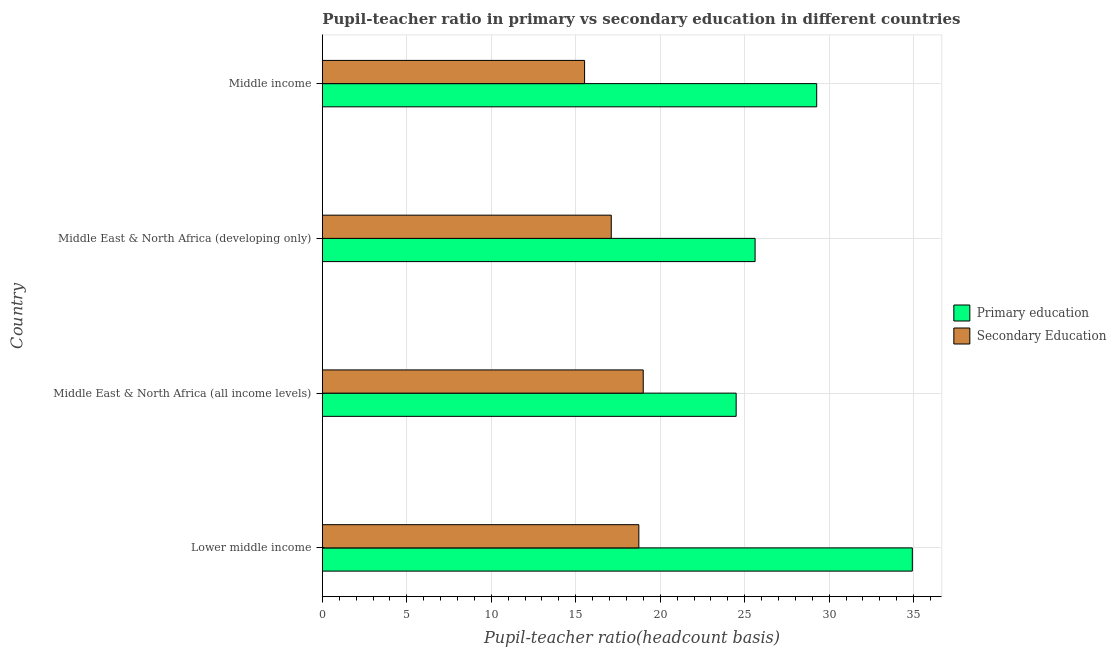How many different coloured bars are there?
Provide a short and direct response. 2. How many groups of bars are there?
Offer a very short reply. 4. Are the number of bars per tick equal to the number of legend labels?
Give a very brief answer. Yes. How many bars are there on the 1st tick from the top?
Your answer should be very brief. 2. How many bars are there on the 2nd tick from the bottom?
Provide a short and direct response. 2. What is the label of the 4th group of bars from the top?
Offer a terse response. Lower middle income. What is the pupil teacher ratio on secondary education in Middle East & North Africa (all income levels)?
Your answer should be compact. 18.99. Across all countries, what is the maximum pupil-teacher ratio in primary education?
Offer a terse response. 34.92. Across all countries, what is the minimum pupil teacher ratio on secondary education?
Ensure brevity in your answer.  15.52. In which country was the pupil-teacher ratio in primary education maximum?
Ensure brevity in your answer.  Lower middle income. In which country was the pupil teacher ratio on secondary education minimum?
Your answer should be compact. Middle income. What is the total pupil teacher ratio on secondary education in the graph?
Your answer should be compact. 70.35. What is the difference between the pupil teacher ratio on secondary education in Lower middle income and that in Middle income?
Ensure brevity in your answer.  3.21. What is the difference between the pupil teacher ratio on secondary education in Middle income and the pupil-teacher ratio in primary education in Middle East & North Africa (developing only)?
Ensure brevity in your answer.  -10.09. What is the average pupil-teacher ratio in primary education per country?
Offer a very short reply. 28.57. What is the difference between the pupil-teacher ratio in primary education and pupil teacher ratio on secondary education in Middle income?
Your response must be concise. 13.74. In how many countries, is the pupil-teacher ratio in primary education greater than 5 ?
Your answer should be compact. 4. What is the ratio of the pupil teacher ratio on secondary education in Lower middle income to that in Middle income?
Your response must be concise. 1.21. Is the pupil teacher ratio on secondary education in Middle East & North Africa (all income levels) less than that in Middle income?
Your response must be concise. No. What is the difference between the highest and the second highest pupil-teacher ratio in primary education?
Your answer should be very brief. 5.66. What is the difference between the highest and the lowest pupil-teacher ratio in primary education?
Ensure brevity in your answer.  10.43. In how many countries, is the pupil-teacher ratio in primary education greater than the average pupil-teacher ratio in primary education taken over all countries?
Offer a very short reply. 2. What does the 2nd bar from the top in Middle income represents?
Ensure brevity in your answer.  Primary education. What does the 1st bar from the bottom in Lower middle income represents?
Provide a short and direct response. Primary education. Are all the bars in the graph horizontal?
Provide a short and direct response. Yes. What is the difference between two consecutive major ticks on the X-axis?
Offer a terse response. 5. Are the values on the major ticks of X-axis written in scientific E-notation?
Make the answer very short. No. Where does the legend appear in the graph?
Give a very brief answer. Center right. How many legend labels are there?
Your answer should be compact. 2. How are the legend labels stacked?
Offer a terse response. Vertical. What is the title of the graph?
Make the answer very short. Pupil-teacher ratio in primary vs secondary education in different countries. What is the label or title of the X-axis?
Make the answer very short. Pupil-teacher ratio(headcount basis). What is the label or title of the Y-axis?
Provide a succinct answer. Country. What is the Pupil-teacher ratio(headcount basis) in Primary education in Lower middle income?
Keep it short and to the point. 34.92. What is the Pupil-teacher ratio(headcount basis) of Secondary Education in Lower middle income?
Offer a terse response. 18.73. What is the Pupil-teacher ratio(headcount basis) in Primary education in Middle East & North Africa (all income levels)?
Your response must be concise. 24.49. What is the Pupil-teacher ratio(headcount basis) of Secondary Education in Middle East & North Africa (all income levels)?
Offer a very short reply. 18.99. What is the Pupil-teacher ratio(headcount basis) of Primary education in Middle East & North Africa (developing only)?
Provide a short and direct response. 25.61. What is the Pupil-teacher ratio(headcount basis) in Secondary Education in Middle East & North Africa (developing only)?
Provide a short and direct response. 17.1. What is the Pupil-teacher ratio(headcount basis) of Primary education in Middle income?
Offer a very short reply. 29.26. What is the Pupil-teacher ratio(headcount basis) in Secondary Education in Middle income?
Your answer should be very brief. 15.52. Across all countries, what is the maximum Pupil-teacher ratio(headcount basis) of Primary education?
Give a very brief answer. 34.92. Across all countries, what is the maximum Pupil-teacher ratio(headcount basis) of Secondary Education?
Offer a terse response. 18.99. Across all countries, what is the minimum Pupil-teacher ratio(headcount basis) of Primary education?
Your answer should be very brief. 24.49. Across all countries, what is the minimum Pupil-teacher ratio(headcount basis) of Secondary Education?
Your response must be concise. 15.52. What is the total Pupil-teacher ratio(headcount basis) of Primary education in the graph?
Offer a very short reply. 114.29. What is the total Pupil-teacher ratio(headcount basis) of Secondary Education in the graph?
Your answer should be very brief. 70.35. What is the difference between the Pupil-teacher ratio(headcount basis) of Primary education in Lower middle income and that in Middle East & North Africa (all income levels)?
Keep it short and to the point. 10.43. What is the difference between the Pupil-teacher ratio(headcount basis) in Secondary Education in Lower middle income and that in Middle East & North Africa (all income levels)?
Provide a succinct answer. -0.26. What is the difference between the Pupil-teacher ratio(headcount basis) in Primary education in Lower middle income and that in Middle East & North Africa (developing only)?
Make the answer very short. 9.31. What is the difference between the Pupil-teacher ratio(headcount basis) in Secondary Education in Lower middle income and that in Middle East & North Africa (developing only)?
Offer a very short reply. 1.63. What is the difference between the Pupil-teacher ratio(headcount basis) in Primary education in Lower middle income and that in Middle income?
Provide a succinct answer. 5.66. What is the difference between the Pupil-teacher ratio(headcount basis) of Secondary Education in Lower middle income and that in Middle income?
Ensure brevity in your answer.  3.21. What is the difference between the Pupil-teacher ratio(headcount basis) in Primary education in Middle East & North Africa (all income levels) and that in Middle East & North Africa (developing only)?
Your answer should be compact. -1.12. What is the difference between the Pupil-teacher ratio(headcount basis) in Secondary Education in Middle East & North Africa (all income levels) and that in Middle East & North Africa (developing only)?
Your response must be concise. 1.89. What is the difference between the Pupil-teacher ratio(headcount basis) of Primary education in Middle East & North Africa (all income levels) and that in Middle income?
Keep it short and to the point. -4.77. What is the difference between the Pupil-teacher ratio(headcount basis) of Secondary Education in Middle East & North Africa (all income levels) and that in Middle income?
Ensure brevity in your answer.  3.47. What is the difference between the Pupil-teacher ratio(headcount basis) of Primary education in Middle East & North Africa (developing only) and that in Middle income?
Keep it short and to the point. -3.65. What is the difference between the Pupil-teacher ratio(headcount basis) in Secondary Education in Middle East & North Africa (developing only) and that in Middle income?
Your response must be concise. 1.58. What is the difference between the Pupil-teacher ratio(headcount basis) of Primary education in Lower middle income and the Pupil-teacher ratio(headcount basis) of Secondary Education in Middle East & North Africa (all income levels)?
Offer a very short reply. 15.93. What is the difference between the Pupil-teacher ratio(headcount basis) in Primary education in Lower middle income and the Pupil-teacher ratio(headcount basis) in Secondary Education in Middle East & North Africa (developing only)?
Provide a succinct answer. 17.82. What is the difference between the Pupil-teacher ratio(headcount basis) in Primary education in Lower middle income and the Pupil-teacher ratio(headcount basis) in Secondary Education in Middle income?
Offer a terse response. 19.4. What is the difference between the Pupil-teacher ratio(headcount basis) of Primary education in Middle East & North Africa (all income levels) and the Pupil-teacher ratio(headcount basis) of Secondary Education in Middle East & North Africa (developing only)?
Offer a very short reply. 7.39. What is the difference between the Pupil-teacher ratio(headcount basis) of Primary education in Middle East & North Africa (all income levels) and the Pupil-teacher ratio(headcount basis) of Secondary Education in Middle income?
Your response must be concise. 8.97. What is the difference between the Pupil-teacher ratio(headcount basis) in Primary education in Middle East & North Africa (developing only) and the Pupil-teacher ratio(headcount basis) in Secondary Education in Middle income?
Your response must be concise. 10.09. What is the average Pupil-teacher ratio(headcount basis) of Primary education per country?
Ensure brevity in your answer.  28.57. What is the average Pupil-teacher ratio(headcount basis) in Secondary Education per country?
Offer a terse response. 17.59. What is the difference between the Pupil-teacher ratio(headcount basis) of Primary education and Pupil-teacher ratio(headcount basis) of Secondary Education in Lower middle income?
Give a very brief answer. 16.19. What is the difference between the Pupil-teacher ratio(headcount basis) in Primary education and Pupil-teacher ratio(headcount basis) in Secondary Education in Middle East & North Africa (all income levels)?
Keep it short and to the point. 5.5. What is the difference between the Pupil-teacher ratio(headcount basis) in Primary education and Pupil-teacher ratio(headcount basis) in Secondary Education in Middle East & North Africa (developing only)?
Ensure brevity in your answer.  8.51. What is the difference between the Pupil-teacher ratio(headcount basis) of Primary education and Pupil-teacher ratio(headcount basis) of Secondary Education in Middle income?
Give a very brief answer. 13.74. What is the ratio of the Pupil-teacher ratio(headcount basis) of Primary education in Lower middle income to that in Middle East & North Africa (all income levels)?
Ensure brevity in your answer.  1.43. What is the ratio of the Pupil-teacher ratio(headcount basis) of Secondary Education in Lower middle income to that in Middle East & North Africa (all income levels)?
Offer a terse response. 0.99. What is the ratio of the Pupil-teacher ratio(headcount basis) in Primary education in Lower middle income to that in Middle East & North Africa (developing only)?
Ensure brevity in your answer.  1.36. What is the ratio of the Pupil-teacher ratio(headcount basis) of Secondary Education in Lower middle income to that in Middle East & North Africa (developing only)?
Keep it short and to the point. 1.1. What is the ratio of the Pupil-teacher ratio(headcount basis) of Primary education in Lower middle income to that in Middle income?
Offer a very short reply. 1.19. What is the ratio of the Pupil-teacher ratio(headcount basis) of Secondary Education in Lower middle income to that in Middle income?
Provide a short and direct response. 1.21. What is the ratio of the Pupil-teacher ratio(headcount basis) in Primary education in Middle East & North Africa (all income levels) to that in Middle East & North Africa (developing only)?
Your response must be concise. 0.96. What is the ratio of the Pupil-teacher ratio(headcount basis) of Secondary Education in Middle East & North Africa (all income levels) to that in Middle East & North Africa (developing only)?
Make the answer very short. 1.11. What is the ratio of the Pupil-teacher ratio(headcount basis) of Primary education in Middle East & North Africa (all income levels) to that in Middle income?
Ensure brevity in your answer.  0.84. What is the ratio of the Pupil-teacher ratio(headcount basis) in Secondary Education in Middle East & North Africa (all income levels) to that in Middle income?
Your response must be concise. 1.22. What is the ratio of the Pupil-teacher ratio(headcount basis) of Primary education in Middle East & North Africa (developing only) to that in Middle income?
Your answer should be very brief. 0.88. What is the ratio of the Pupil-teacher ratio(headcount basis) in Secondary Education in Middle East & North Africa (developing only) to that in Middle income?
Make the answer very short. 1.1. What is the difference between the highest and the second highest Pupil-teacher ratio(headcount basis) of Primary education?
Keep it short and to the point. 5.66. What is the difference between the highest and the second highest Pupil-teacher ratio(headcount basis) in Secondary Education?
Your response must be concise. 0.26. What is the difference between the highest and the lowest Pupil-teacher ratio(headcount basis) of Primary education?
Give a very brief answer. 10.43. What is the difference between the highest and the lowest Pupil-teacher ratio(headcount basis) in Secondary Education?
Give a very brief answer. 3.47. 